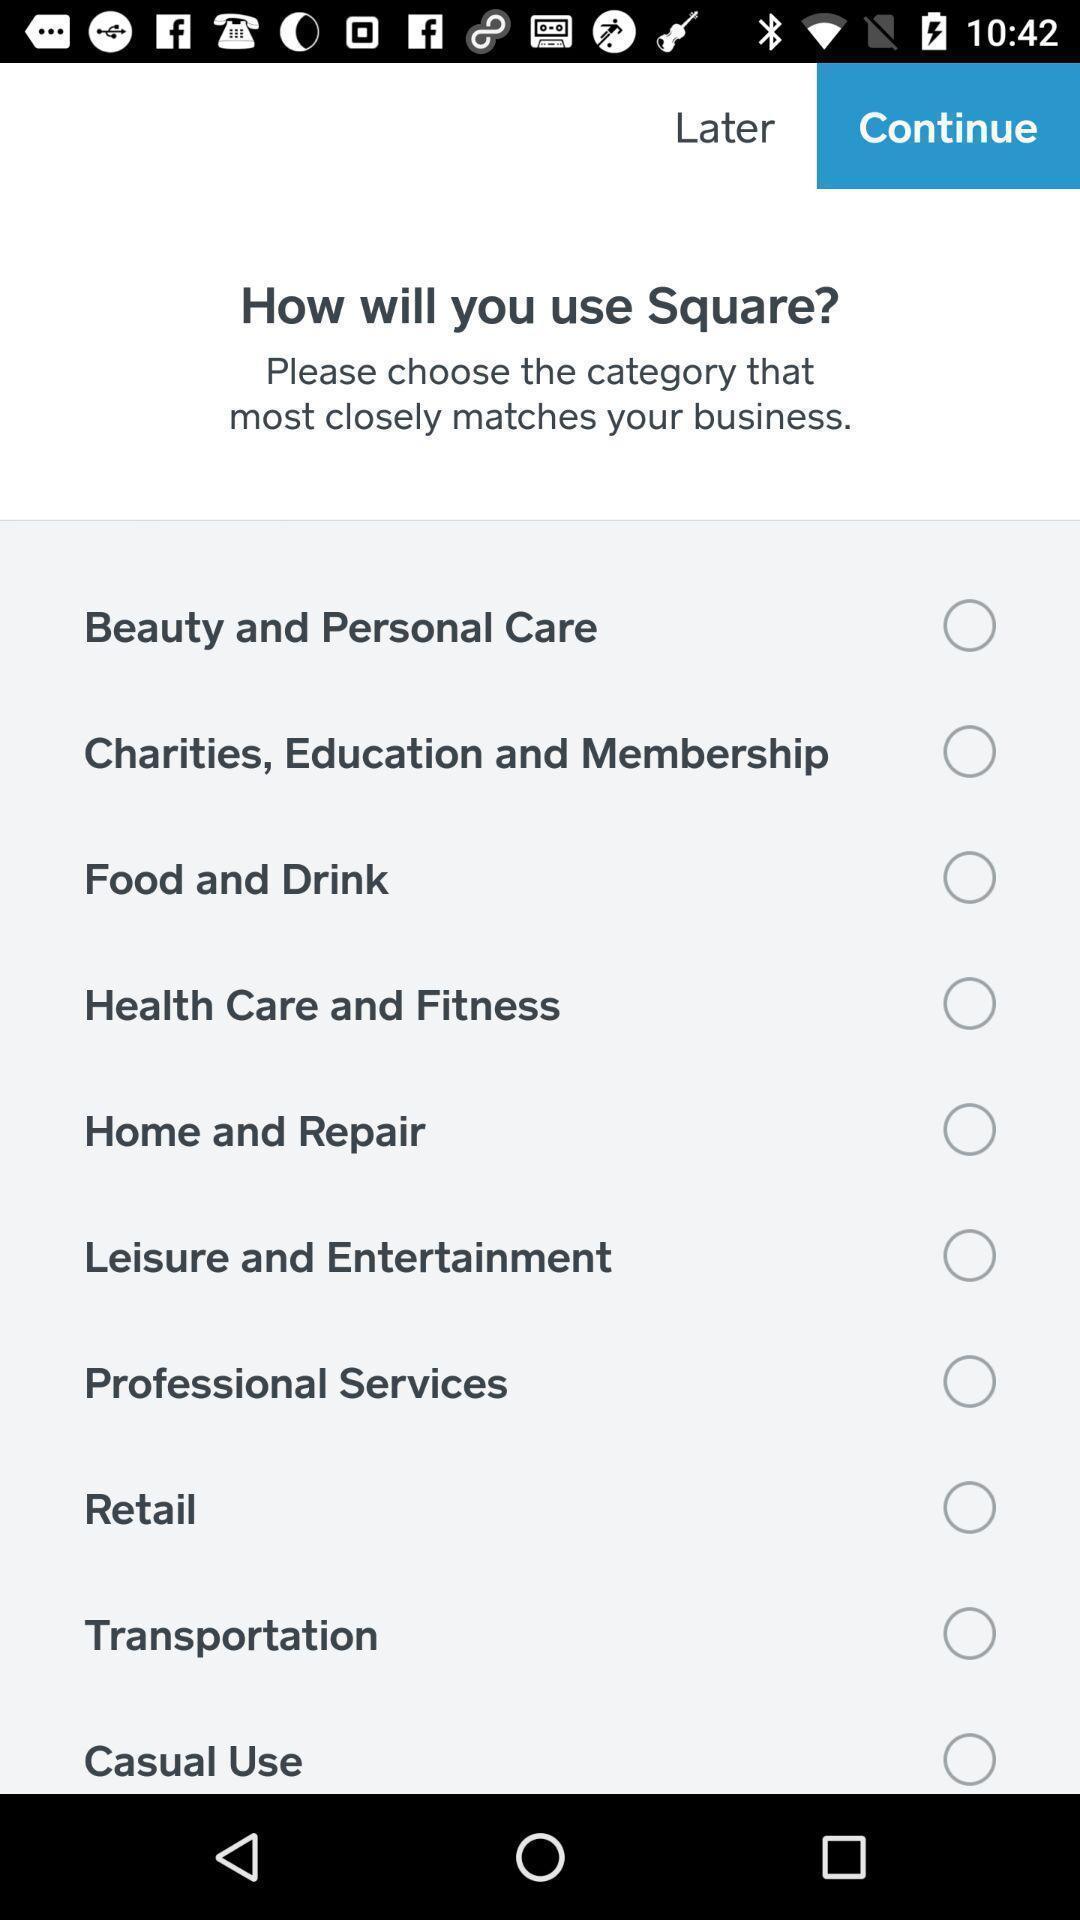Provide a description of this screenshot. Question in the application regarding use of the square. 